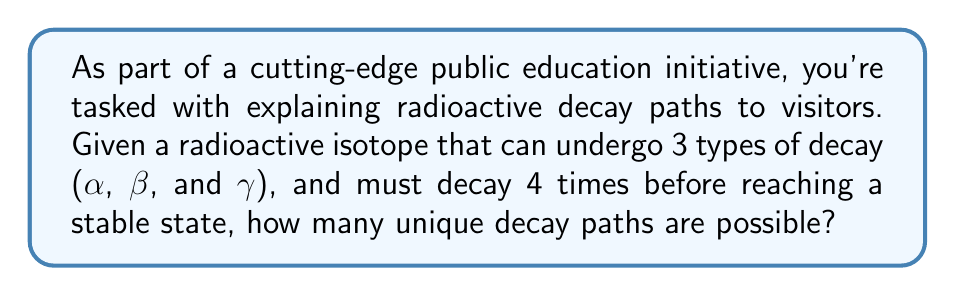Can you answer this question? Let's approach this step-by-step:

1) We can think of this as a sequence of 4 choices, where each choice can be one of 3 types of decay.

2) This is a classic example of the multiplication principle in combinatorics.

3) For each step in the decay process, we have 3 choices (alpha, beta, or gamma).

4) We need to make this choice 4 times in succession.

5) Therefore, the total number of possible paths is:

   $$3 \times 3 \times 3 \times 3 = 3^4$$

6) We can calculate this:

   $$3^4 = 3 \times 3 \times 3 \times 3 = 81$$

Thus, there are 81 possible unique decay paths for this isotope.

This calculation demonstrates the complexity and variability in radioactive decay processes, highlighting the importance of understanding and monitoring these processes in nuclear power plant operations.
Answer: $81$ 